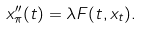<formula> <loc_0><loc_0><loc_500><loc_500>x _ { \pi } ^ { \prime \prime } ( t ) = \lambda F ( t , x _ { t } ) .</formula> 